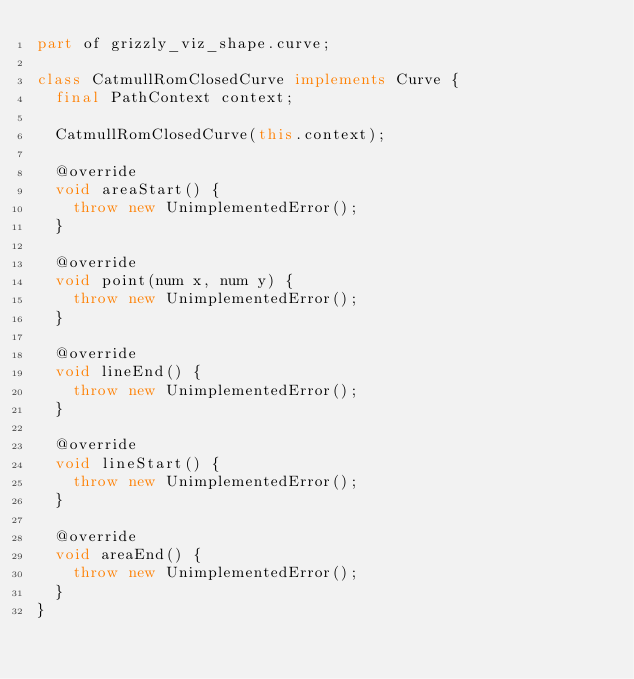<code> <loc_0><loc_0><loc_500><loc_500><_Dart_>part of grizzly_viz_shape.curve;

class CatmullRomClosedCurve implements Curve {
  final PathContext context;

  CatmullRomClosedCurve(this.context);

  @override
  void areaStart() {
    throw new UnimplementedError();
  }

  @override
  void point(num x, num y) {
    throw new UnimplementedError();
  }

  @override
  void lineEnd() {
    throw new UnimplementedError();
  }

  @override
  void lineStart() {
    throw new UnimplementedError();
  }

  @override
  void areaEnd() {
    throw new UnimplementedError();
  }
}</code> 